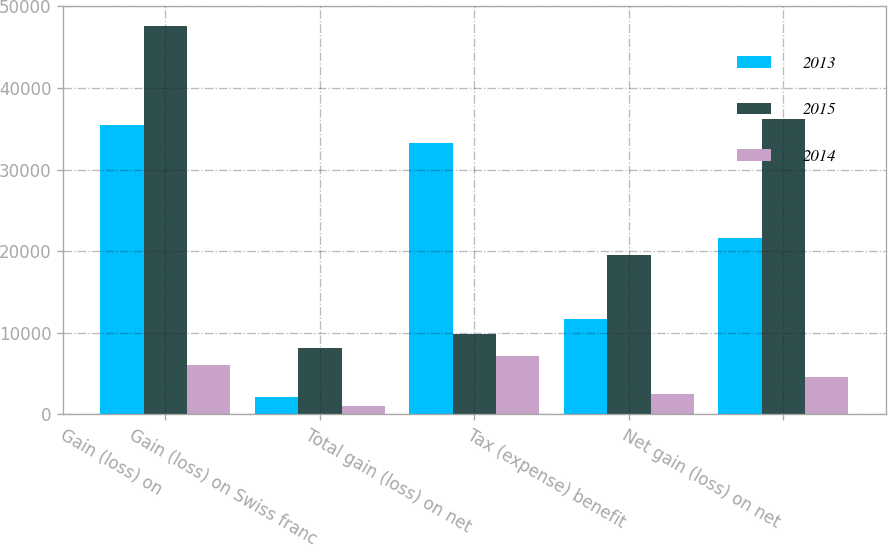Convert chart to OTSL. <chart><loc_0><loc_0><loc_500><loc_500><stacked_bar_chart><ecel><fcel>Gain (loss) on<fcel>Gain (loss) on Swiss franc<fcel>Total gain (loss) on net<fcel>Tax (expense) benefit<fcel>Net gain (loss) on net<nl><fcel>2013<fcel>35458<fcel>2185<fcel>33273<fcel>11646<fcel>21627<nl><fcel>2015<fcel>47630<fcel>8149<fcel>9897.5<fcel>19523<fcel>36256<nl><fcel>2014<fcel>6099<fcel>1035<fcel>7134<fcel>2494<fcel>4640<nl></chart> 